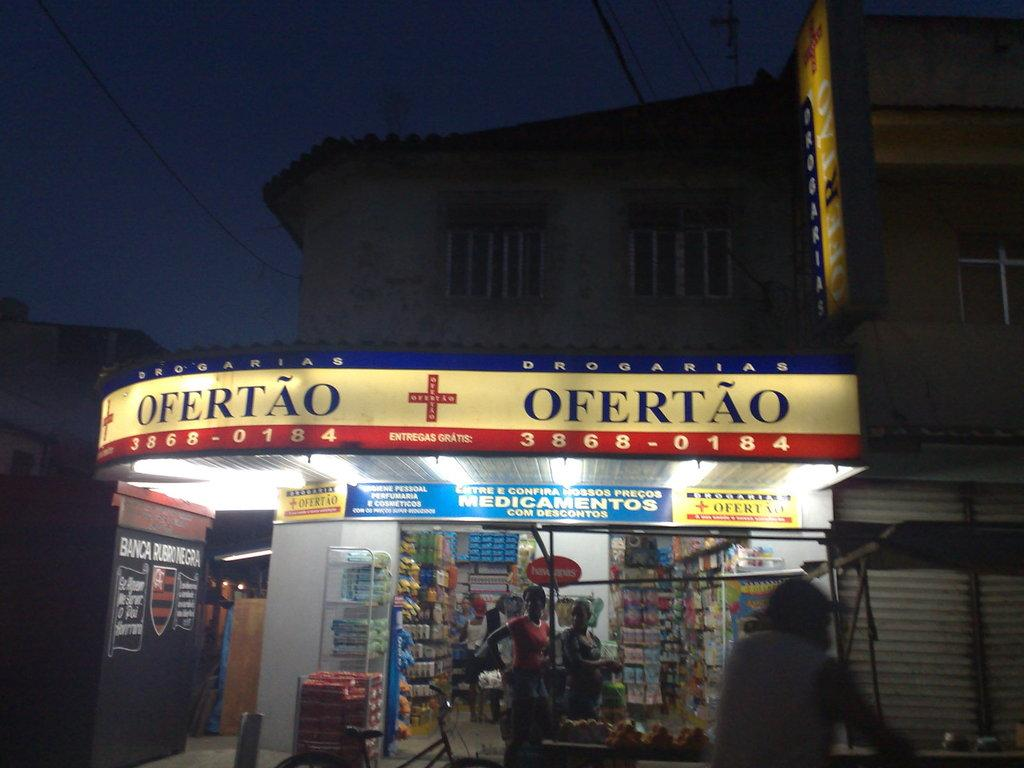<image>
Offer a succinct explanation of the picture presented. Corner store with a sign saying Ofertao and the number 38680184. 